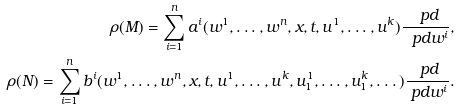Convert formula to latex. <formula><loc_0><loc_0><loc_500><loc_500>\rho ( M ) = \sum _ { i = 1 } ^ { n } a ^ { i } ( w ^ { 1 } , \dots , w ^ { n } , x , t , u ^ { 1 } , \dots , u ^ { k } ) \frac { \ p d } { \ p d w ^ { i } } , \\ \rho ( N ) = \sum _ { i = 1 } ^ { n } b ^ { i } ( w ^ { 1 } , \dots , w ^ { n } , x , t , u ^ { 1 } , \dots , u ^ { k } , u _ { 1 } ^ { 1 } , \dots , u ^ { k } _ { 1 } , \dots ) \frac { \ p d } { \ p d w ^ { i } } .</formula> 